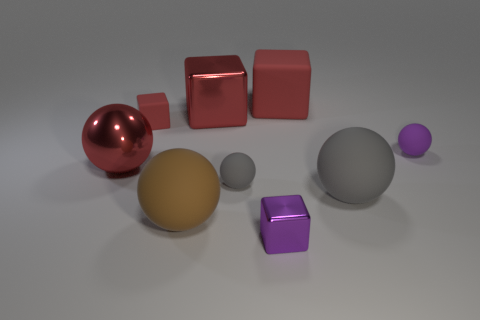There is a brown object that is the same shape as the tiny purple matte object; what material is it?
Keep it short and to the point. Rubber. There is a tiny block that is the same color as the big metal cube; what is its material?
Give a very brief answer. Rubber. There is a brown object that is the same size as the metal sphere; what is its material?
Your response must be concise. Rubber. What number of objects are large metallic objects left of the large brown rubber sphere or red balls in front of the big red shiny block?
Your response must be concise. 1. Is the number of gray balls less than the number of red things?
Ensure brevity in your answer.  Yes. What shape is the gray rubber thing that is the same size as the brown sphere?
Offer a terse response. Sphere. What number of other objects are the same color as the metal sphere?
Give a very brief answer. 3. What number of things are there?
Ensure brevity in your answer.  9. What number of balls are both behind the large gray rubber thing and to the right of the large rubber block?
Ensure brevity in your answer.  1. What is the small purple sphere made of?
Your response must be concise. Rubber. 